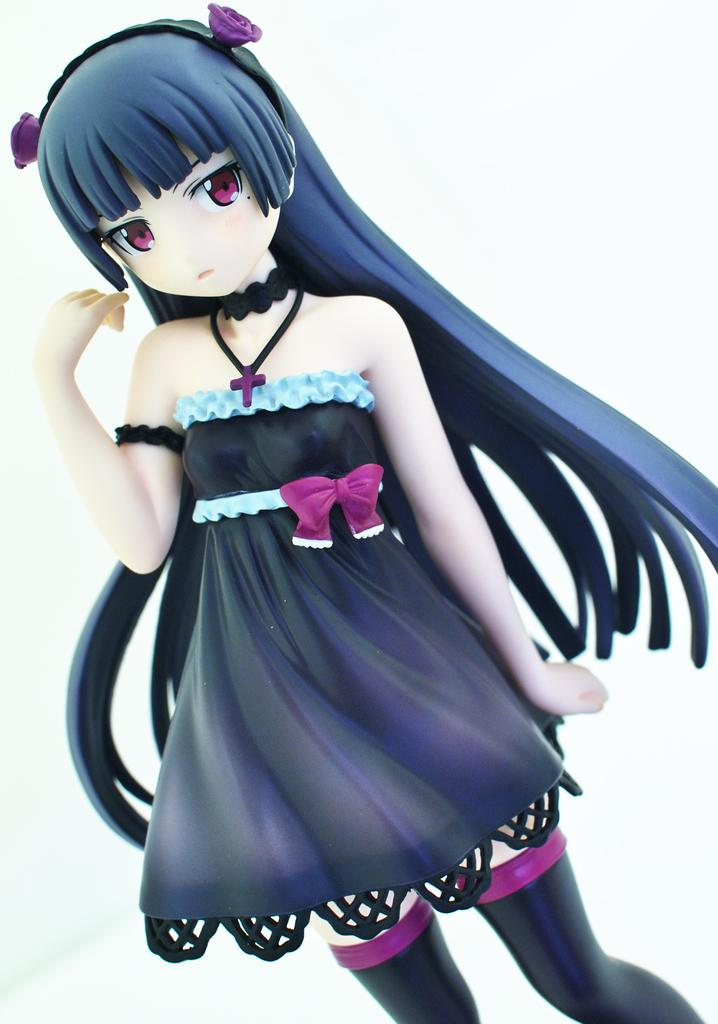What is the main subject in the image? There is a doll in the image. What color is the background of the image? The background of the image is white. How does the doll contribute to the growth of the plants in the image? There are no plants present in the image, so the doll does not contribute to their growth. 